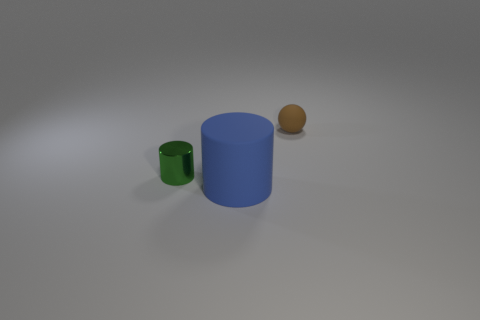There is a matte object on the left side of the tiny brown rubber thing right of the green object; what color is it?
Make the answer very short. Blue. The large thing is what color?
Make the answer very short. Blue. Are there any rubber spheres of the same color as the large cylinder?
Provide a short and direct response. No. There is a matte thing that is in front of the metallic cylinder; is it the same color as the sphere?
Offer a very short reply. No. How many objects are either objects that are in front of the small brown sphere or blue shiny cylinders?
Ensure brevity in your answer.  2. Are there any small matte balls to the right of the big matte object?
Offer a terse response. Yes. Is the material of the tiny thing that is in front of the small sphere the same as the brown sphere?
Provide a succinct answer. No. Is there a tiny green thing left of the small object to the left of the rubber thing in front of the tiny metal object?
Your response must be concise. No. What number of blocks are either green shiny objects or small matte objects?
Your answer should be very brief. 0. There is a tiny object in front of the tiny brown object; what is its material?
Your answer should be compact. Metal. 